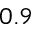<formula> <loc_0><loc_0><loc_500><loc_500>0 . 9</formula> 